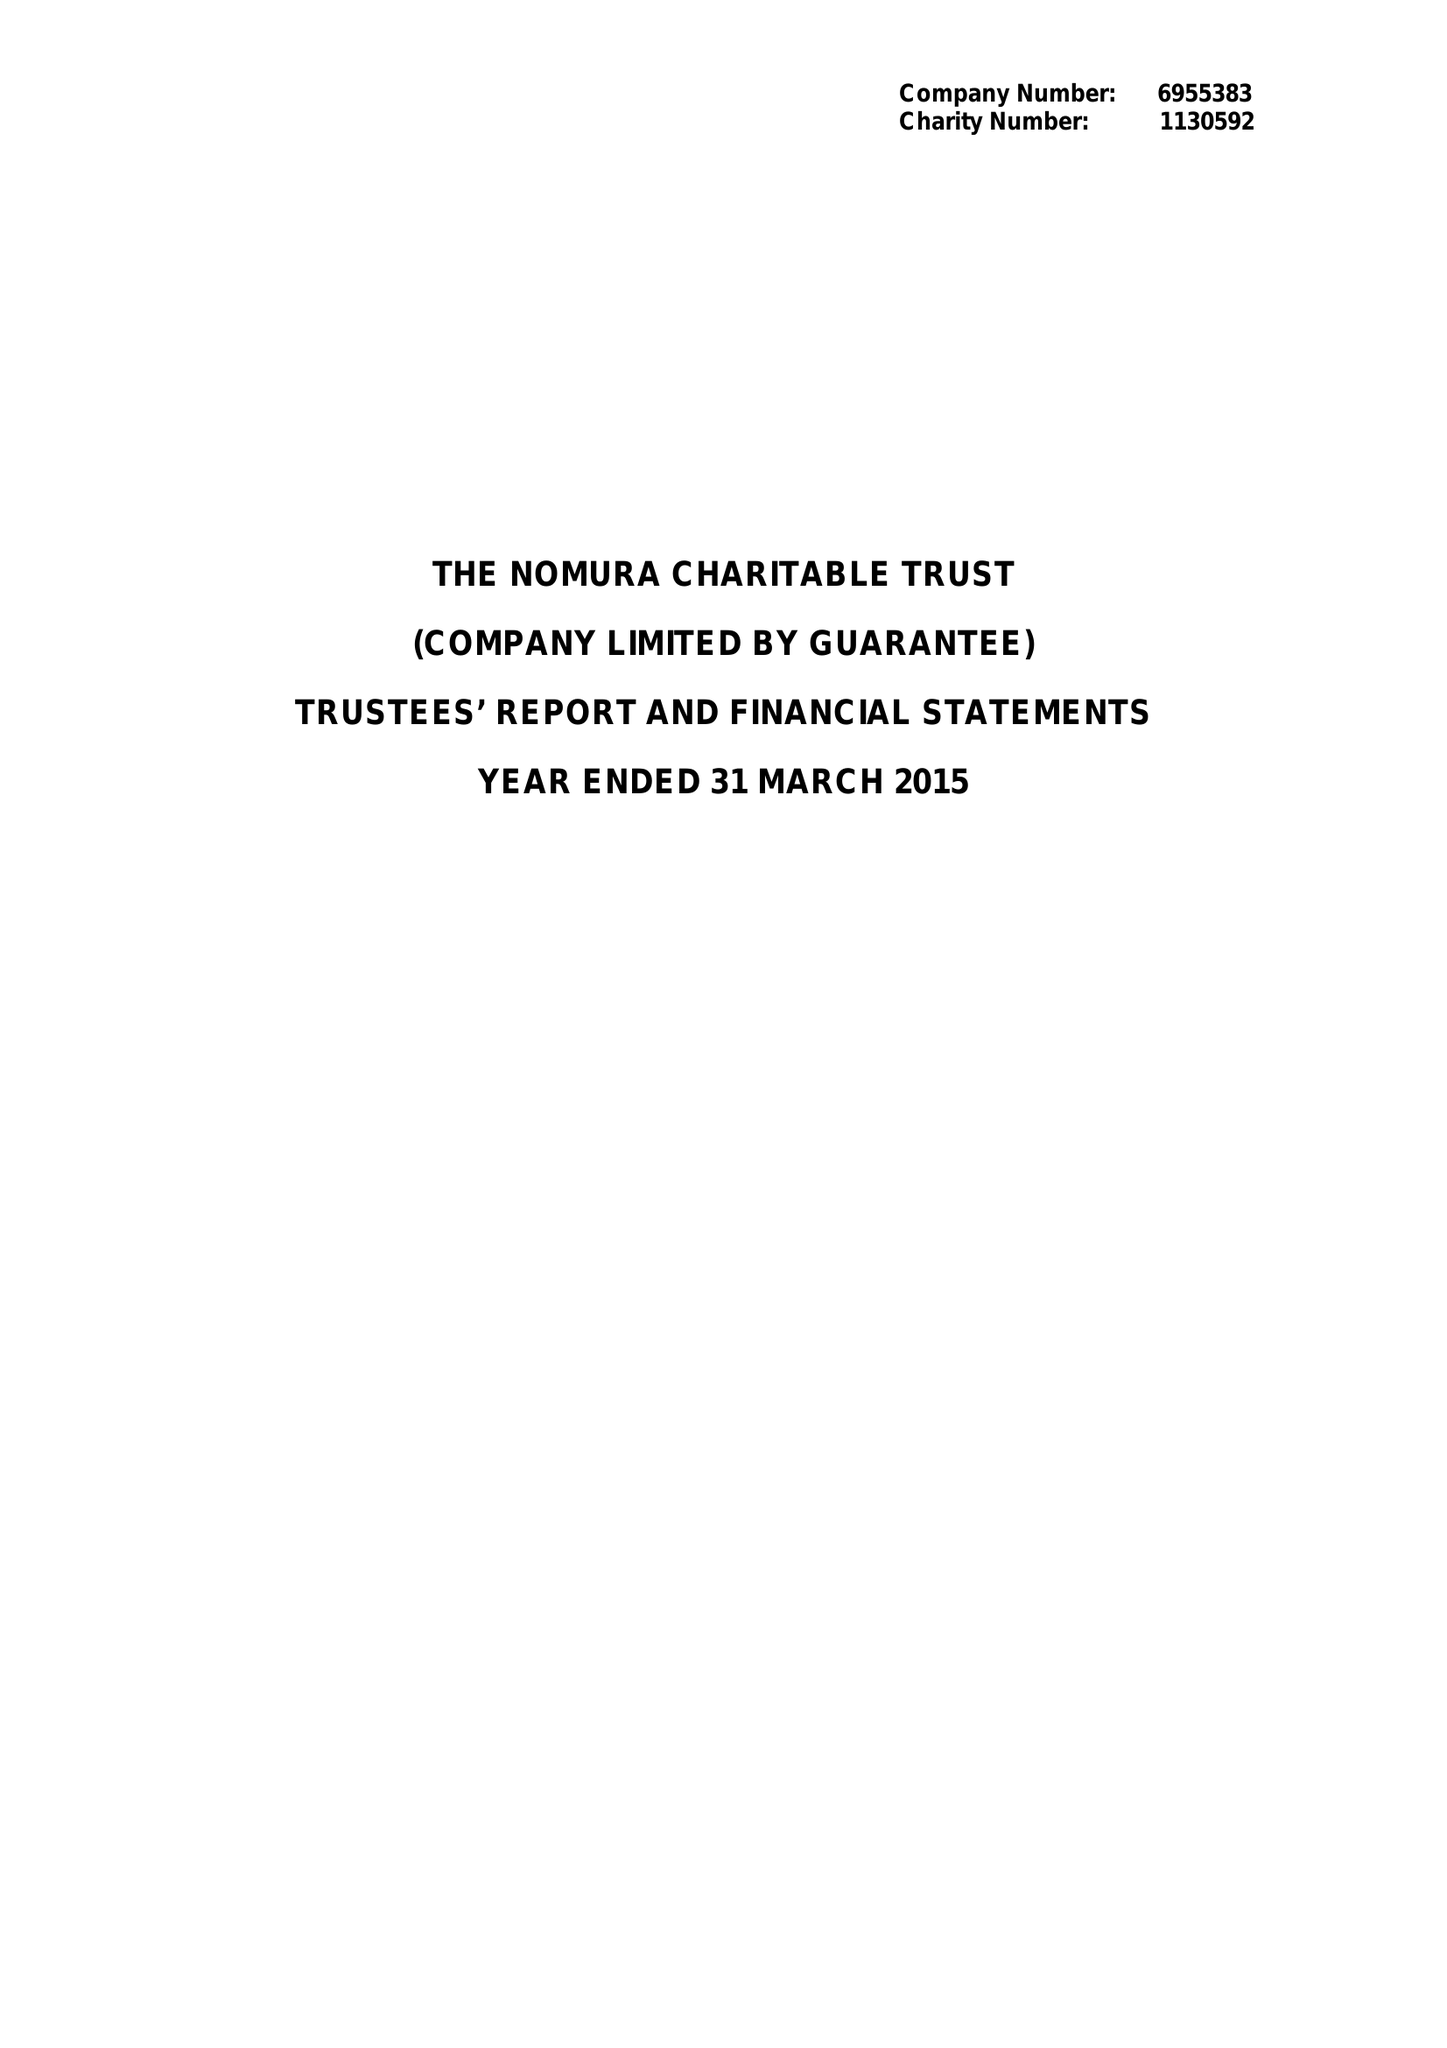What is the value for the charity_name?
Answer the question using a single word or phrase. The Nomura Charitable Trust 